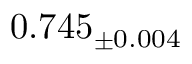Convert formula to latex. <formula><loc_0><loc_0><loc_500><loc_500>0 . 7 4 5 _ { \pm 0 . 0 0 4 }</formula> 